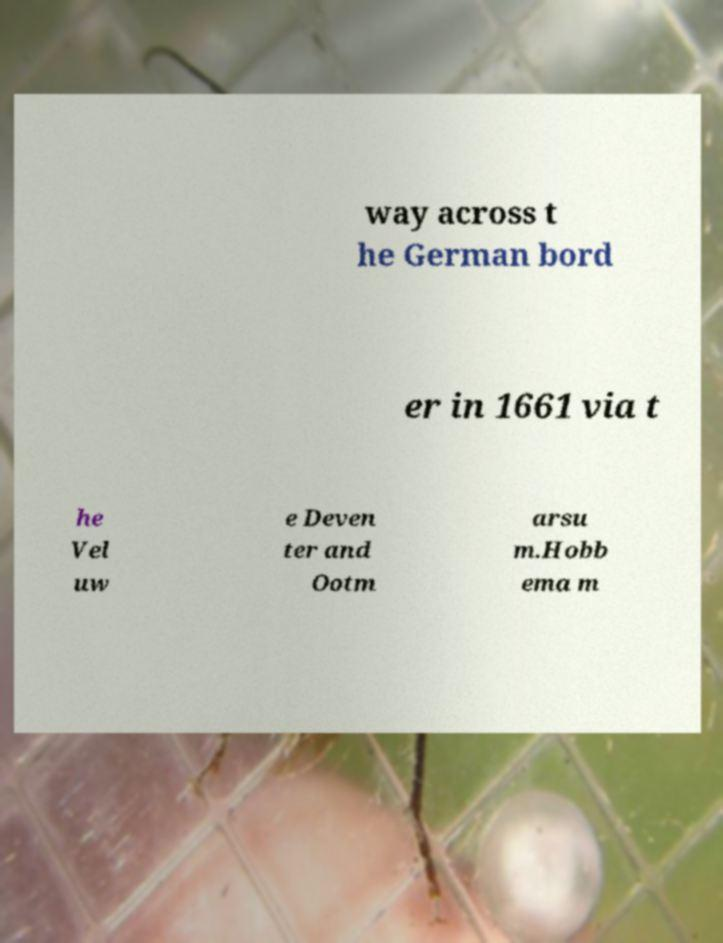Could you assist in decoding the text presented in this image and type it out clearly? way across t he German bord er in 1661 via t he Vel uw e Deven ter and Ootm arsu m.Hobb ema m 